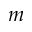Convert formula to latex. <formula><loc_0><loc_0><loc_500><loc_500>m</formula> 